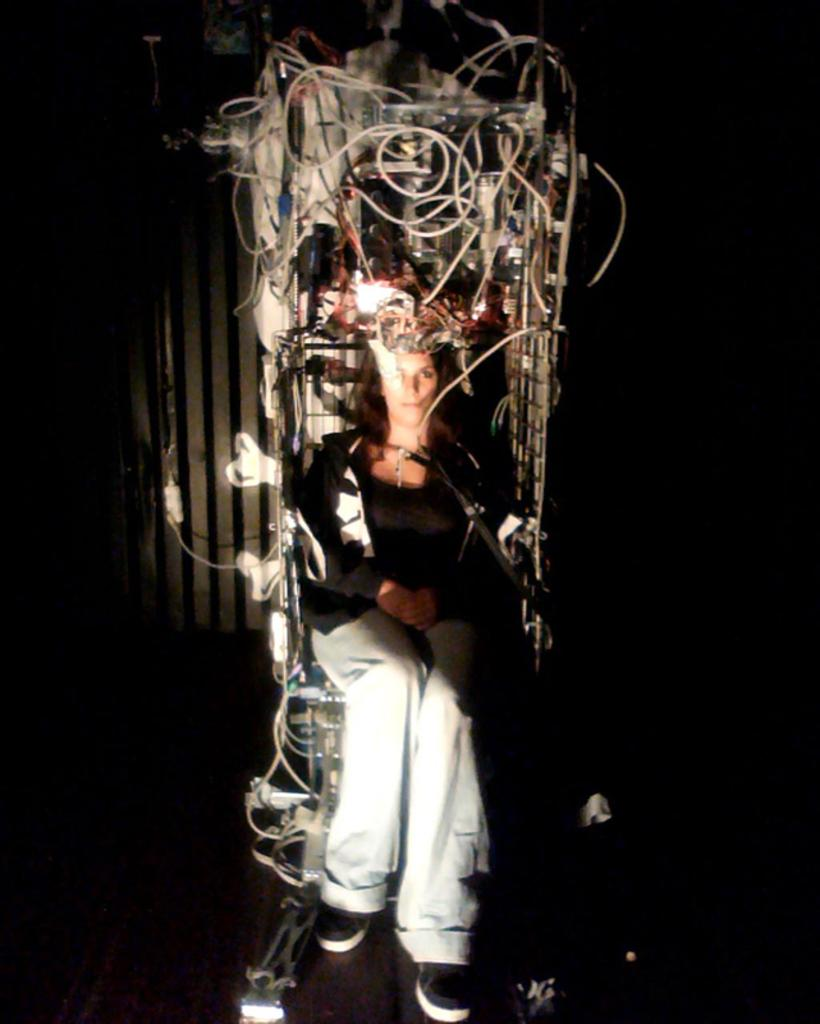What is the overall color scheme of the image? The background of the image is dark. What is the person in the image doing? The person is sitting on an electrical object in the image. What type of camera can be seen in the image? There is no camera present in the image. What payment method is being used by the person in the image? There is no payment method being used in the image; the person is simply sitting on an electrical object. 